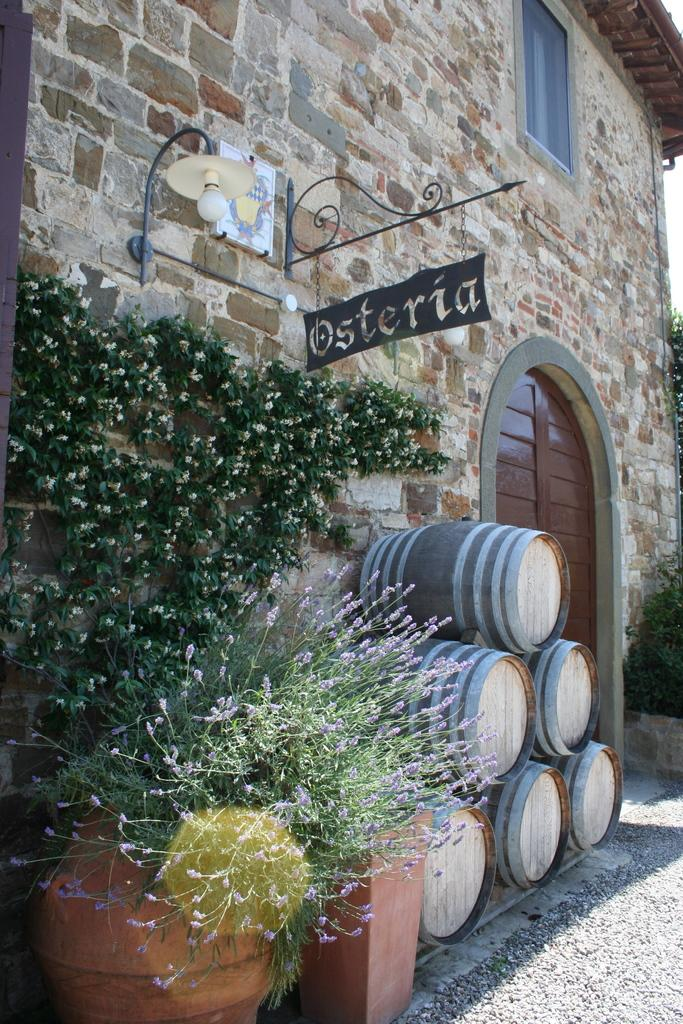What type of structure is present in the image? There is a building in the image. Can you describe the lighting in the image? There is light in the image. What musical instruments can be seen in the image? There are drums in the image. What type of vegetation is present in the image? There are plants in the image. Where is the hen located in the image? There is no hen present in the image. What type of market can be seen in the image? There is no market present in the image. 